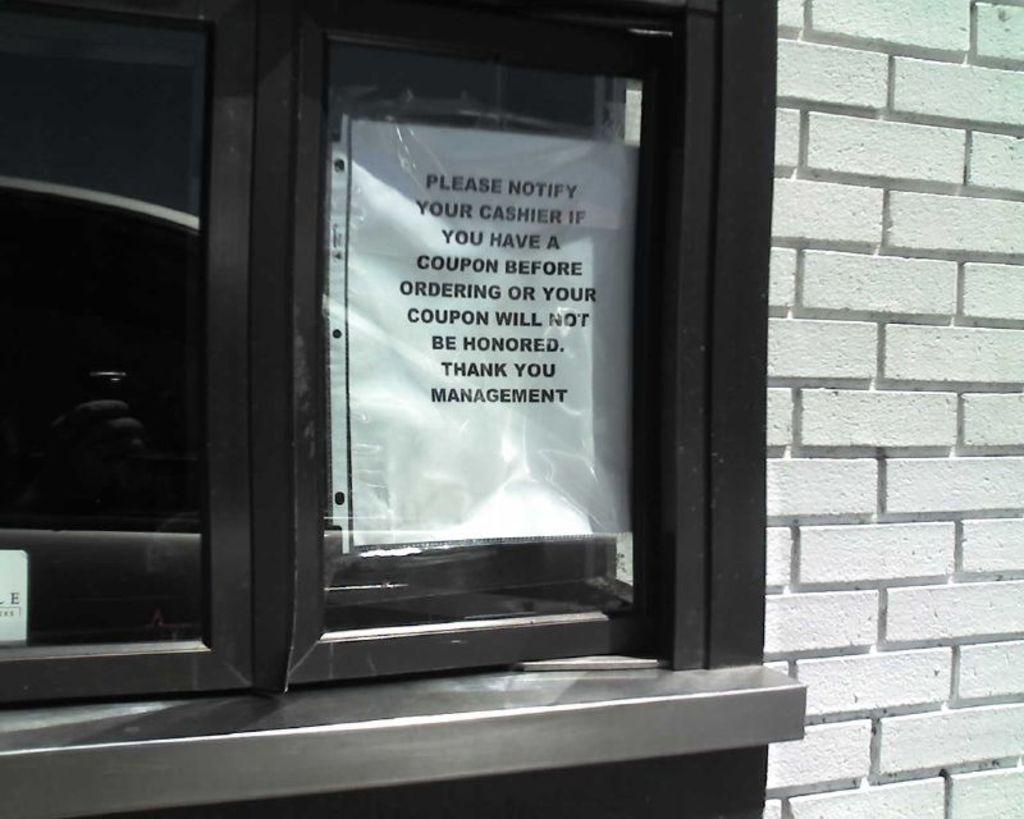<image>
Summarize the visual content of the image. The management of this establishment left a notice on the window for their customers. 